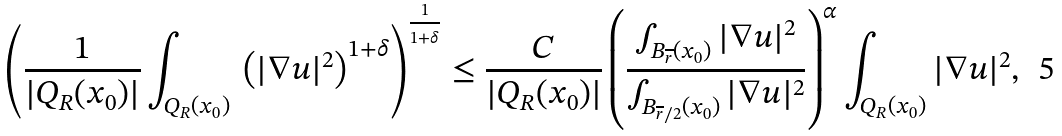<formula> <loc_0><loc_0><loc_500><loc_500>\left ( \frac { 1 } { | Q _ { R } ( x _ { 0 } ) | } \int _ { Q _ { R } ( x _ { 0 } ) } \, \left ( | \nabla u | ^ { 2 } \right ) ^ { 1 + \delta } \right ) ^ { \frac { 1 } { 1 + \delta } } \leq \frac { C } { | Q _ { R } ( x _ { 0 } ) | } \left ( \frac { \int _ { B _ { \overline { r } } ( x _ { 0 } ) } | \nabla u | ^ { 2 } } { \int _ { B _ { \overline { r } / 2 } ( x _ { 0 } ) } | \nabla u | ^ { 2 } } \right ) ^ { \alpha } \int _ { Q _ { R } ( x _ { 0 } ) } | \nabla u | ^ { 2 } ,</formula> 